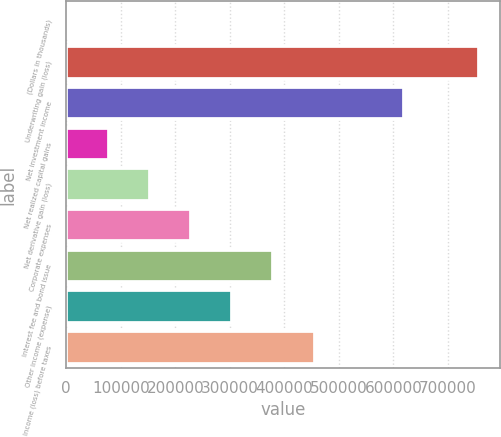<chart> <loc_0><loc_0><loc_500><loc_500><bar_chart><fcel>(Dollars in thousands)<fcel>Underwriting gain (loss)<fcel>Net investment income<fcel>Net realized capital gains<fcel>Net derivative gain (loss)<fcel>Corporate expenses<fcel>Interest fee and bond issue<fcel>Other income (expense)<fcel>Income (loss) before taxes<nl><fcel>2011<fcel>757781<fcel>620041<fcel>77588<fcel>153165<fcel>228742<fcel>379896<fcel>304319<fcel>455473<nl></chart> 